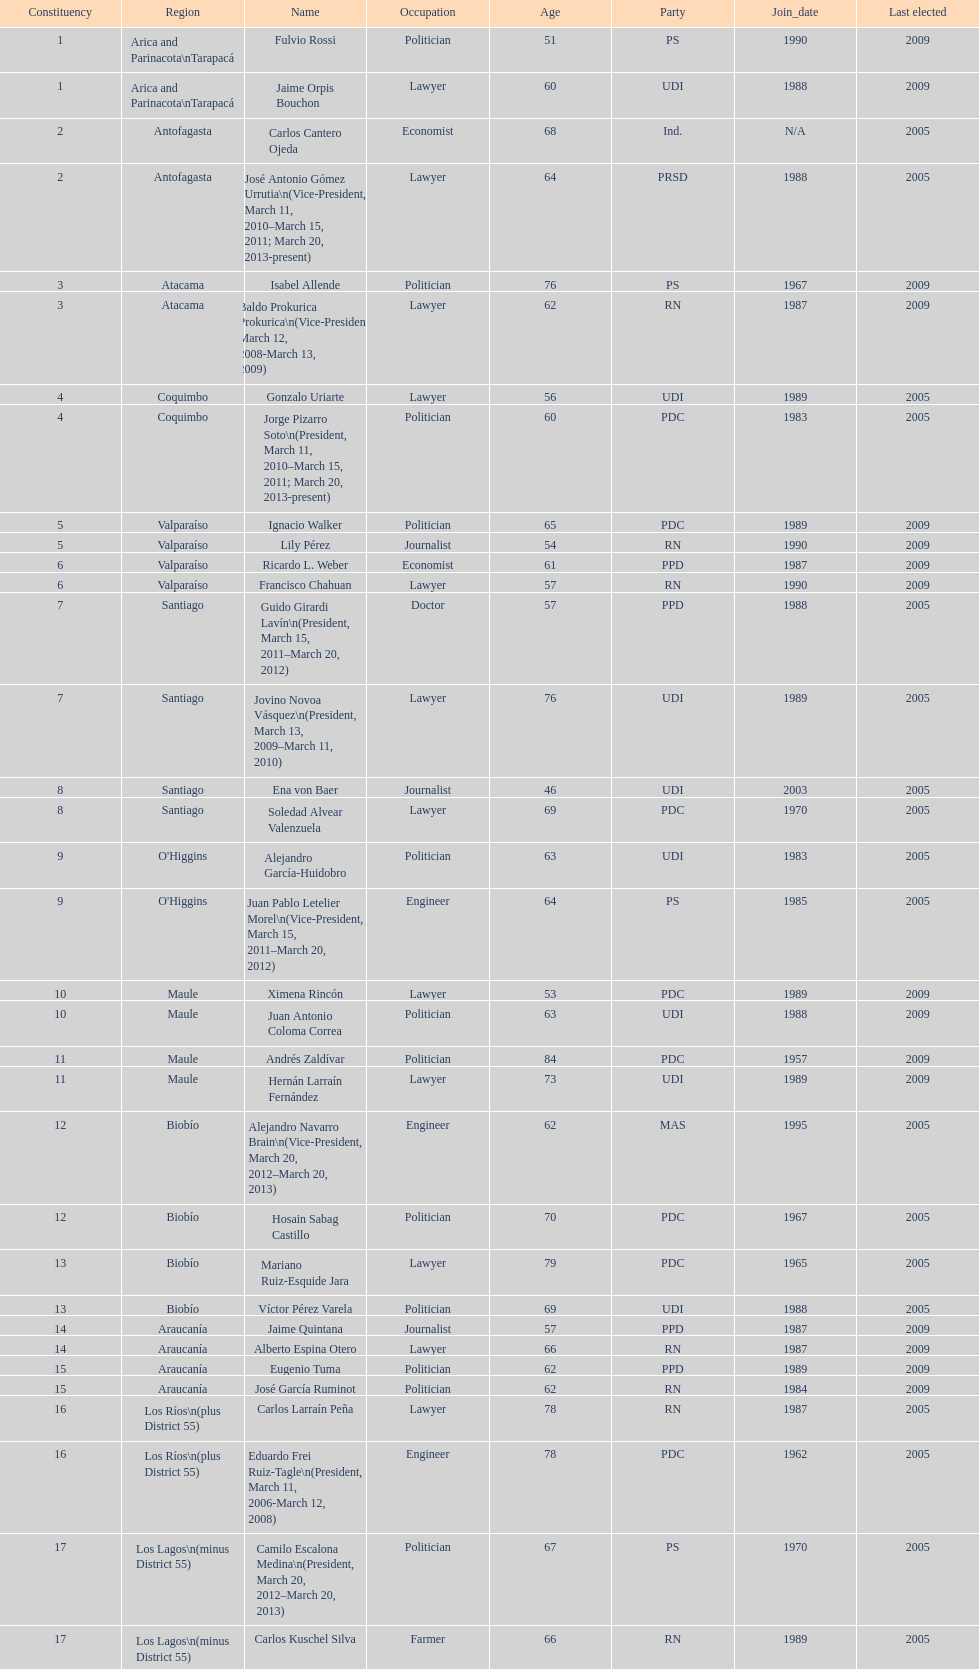What is the total number of constituencies? 19. 